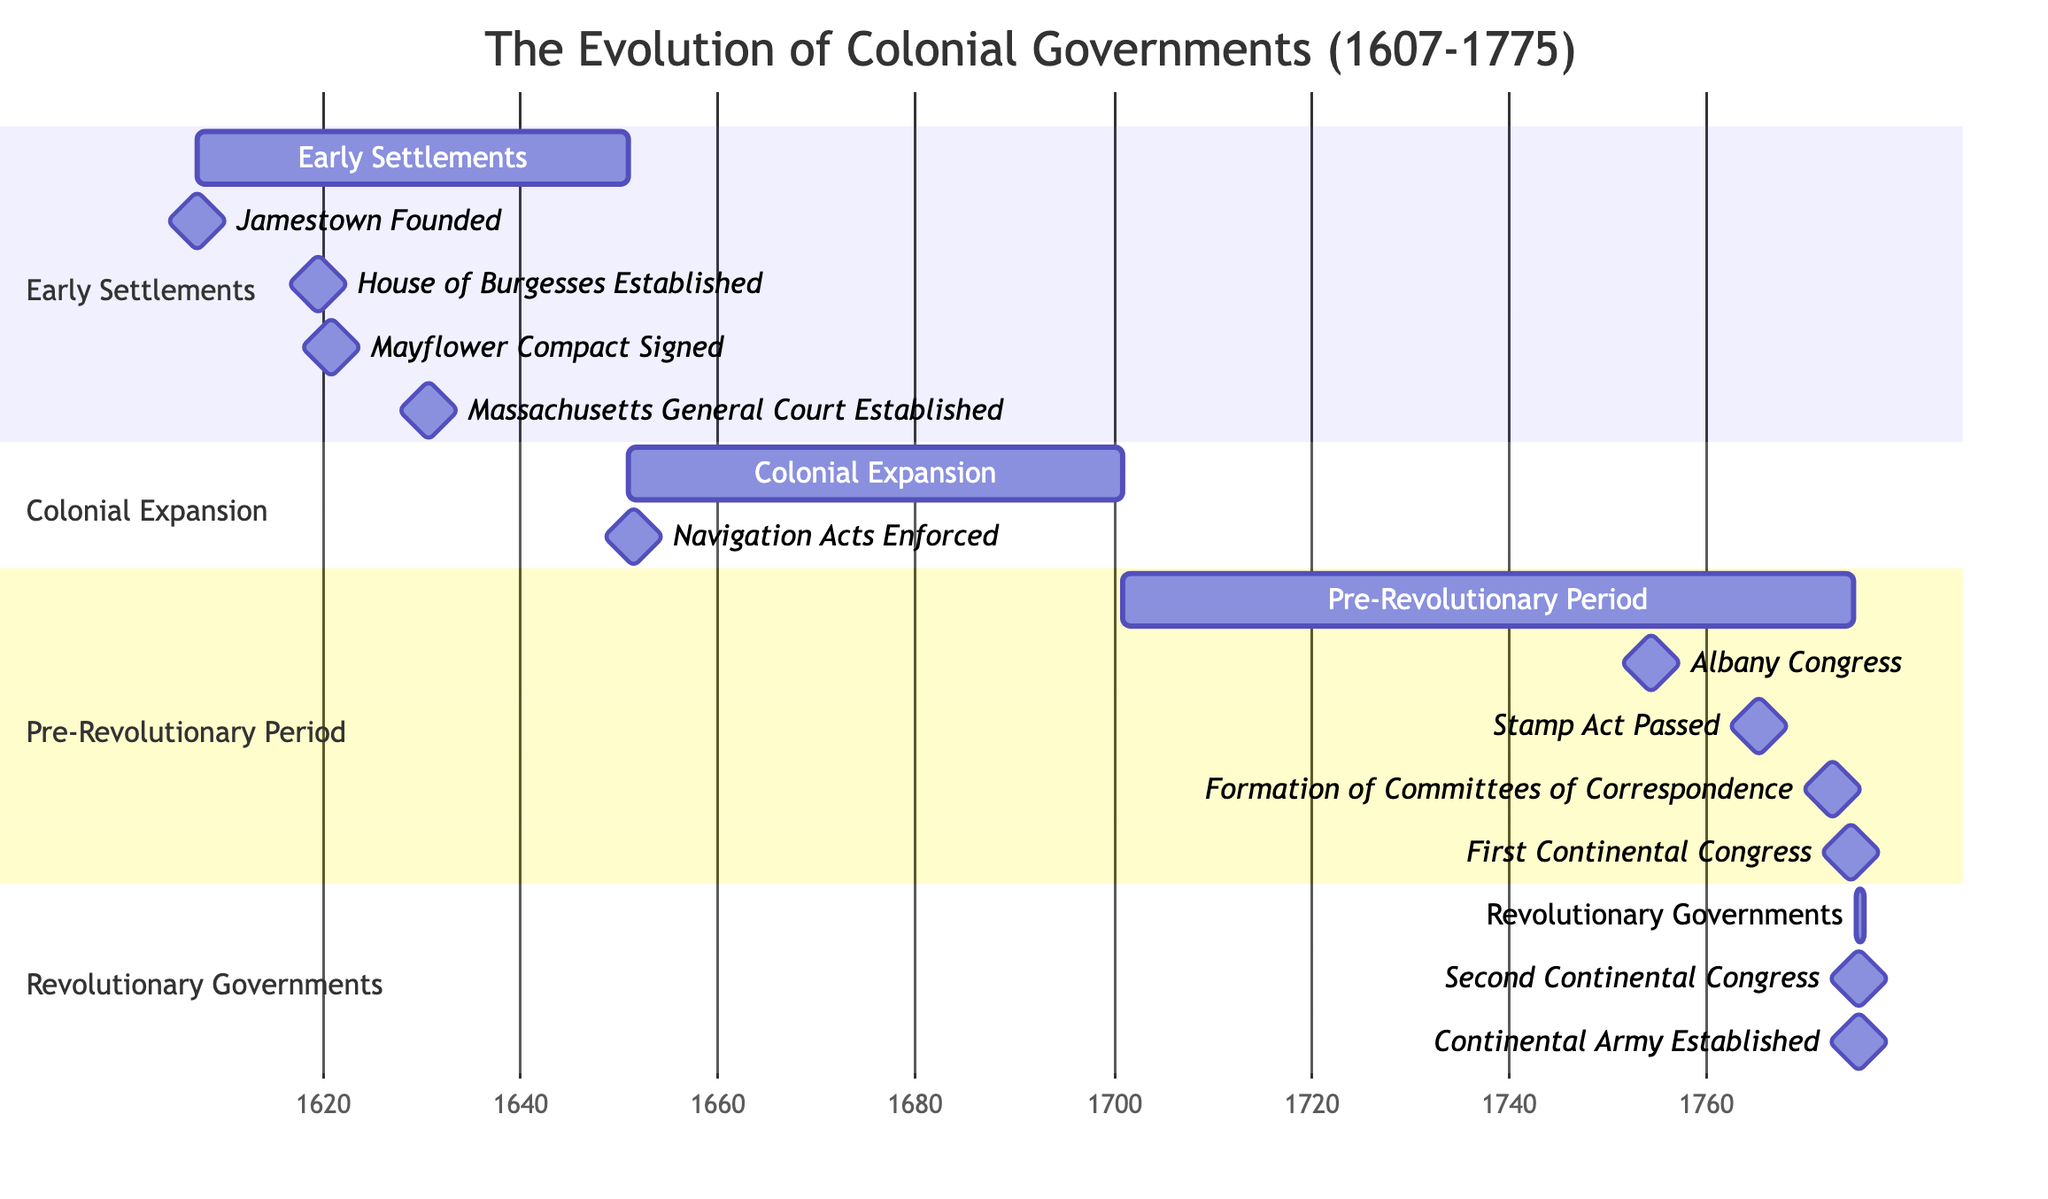What is the starting date of the Early Settlements phase? The Early Settlements phase starts on May 1607, as indicated at the beginning of that section in the diagram.
Answer: May 1607 How many milestones are there in the Pre-Revolutionary Period? In the Pre-Revolutionary Period section of the Gantt chart, there are four milestones listed: Albany Congress, Stamp Act Passed, Formation of Committees of Correspondence, and First Continental Congress. Thus, the total count is four.
Answer: 4 Which milestone occurred first in the Revolutionary Governments phase? In the Revolutionary Governments section, the two milestones listed are the Second Continental Congress and the Continental Army Established. The Second Continental Congress, which occurs in May 1775, is earlier than the Continental Army, which is established in June 1775.
Answer: Second Continental Congress What is the relationship between the Navigation Acts Enforced and the Colonial Expansion phase? The Navigation Acts Enforced milestone is situated within the Colonial Expansion phase, making it a landmark event that signifies control over colonial trade and marks progress within that time frame.
Answer: Within Colonial Expansion phase Which phase has the most milestones represented on the chart? Looking at all the given phases in the Gantt chart, the Pre-Revolutionary Period contains four distinct milestones, which is more than any other phase. The other phases have fewer milestones, indicating that this phase has the most.
Answer: Pre-Revolutionary Period At what date was the House of Burgesses Established? The House of Burgesses was established in July 1619, as shown in the Early Settlements phase under its milestones.
Answer: July 1619 When was the first Continental Congress held? The first Continental Congress was held in September 1774, which can be found listed among the milestones in the Pre-Revolutionary Period.
Answer: September 1774 How long did the Early Settlements phase last? The Early Settlements phase spans from May 1607 to December 1650. To find the duration, we evaluate these dates, which indicates this phase lasted for approximately 43 years.
Answer: 43 years What is the title of this Gantt Chart? The title displayed at the top of the Gantt Chart is "The Evolution of Colonial Governments (1607-1775)", which summarizes the primary focus of the chart's content.
Answer: The Evolution of Colonial Governments (1607-1775) 